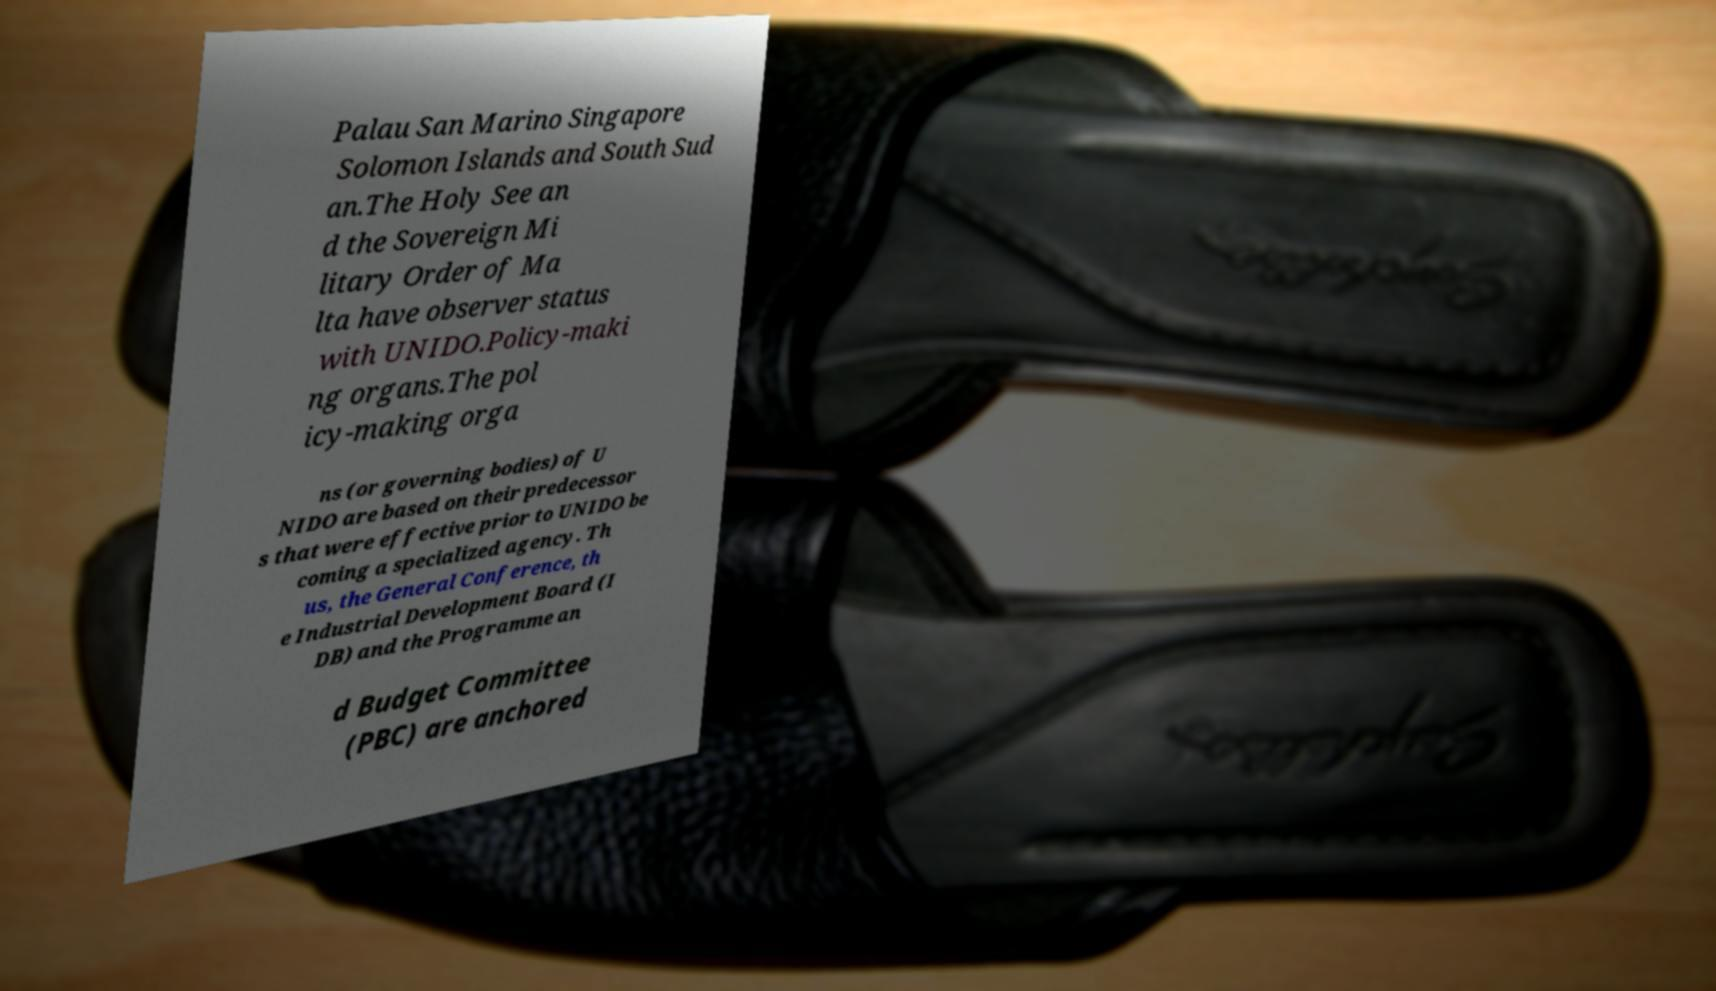I need the written content from this picture converted into text. Can you do that? Palau San Marino Singapore Solomon Islands and South Sud an.The Holy See an d the Sovereign Mi litary Order of Ma lta have observer status with UNIDO.Policy-maki ng organs.The pol icy-making orga ns (or governing bodies) of U NIDO are based on their predecessor s that were effective prior to UNIDO be coming a specialized agency. Th us, the General Conference, th e Industrial Development Board (I DB) and the Programme an d Budget Committee (PBC) are anchored 